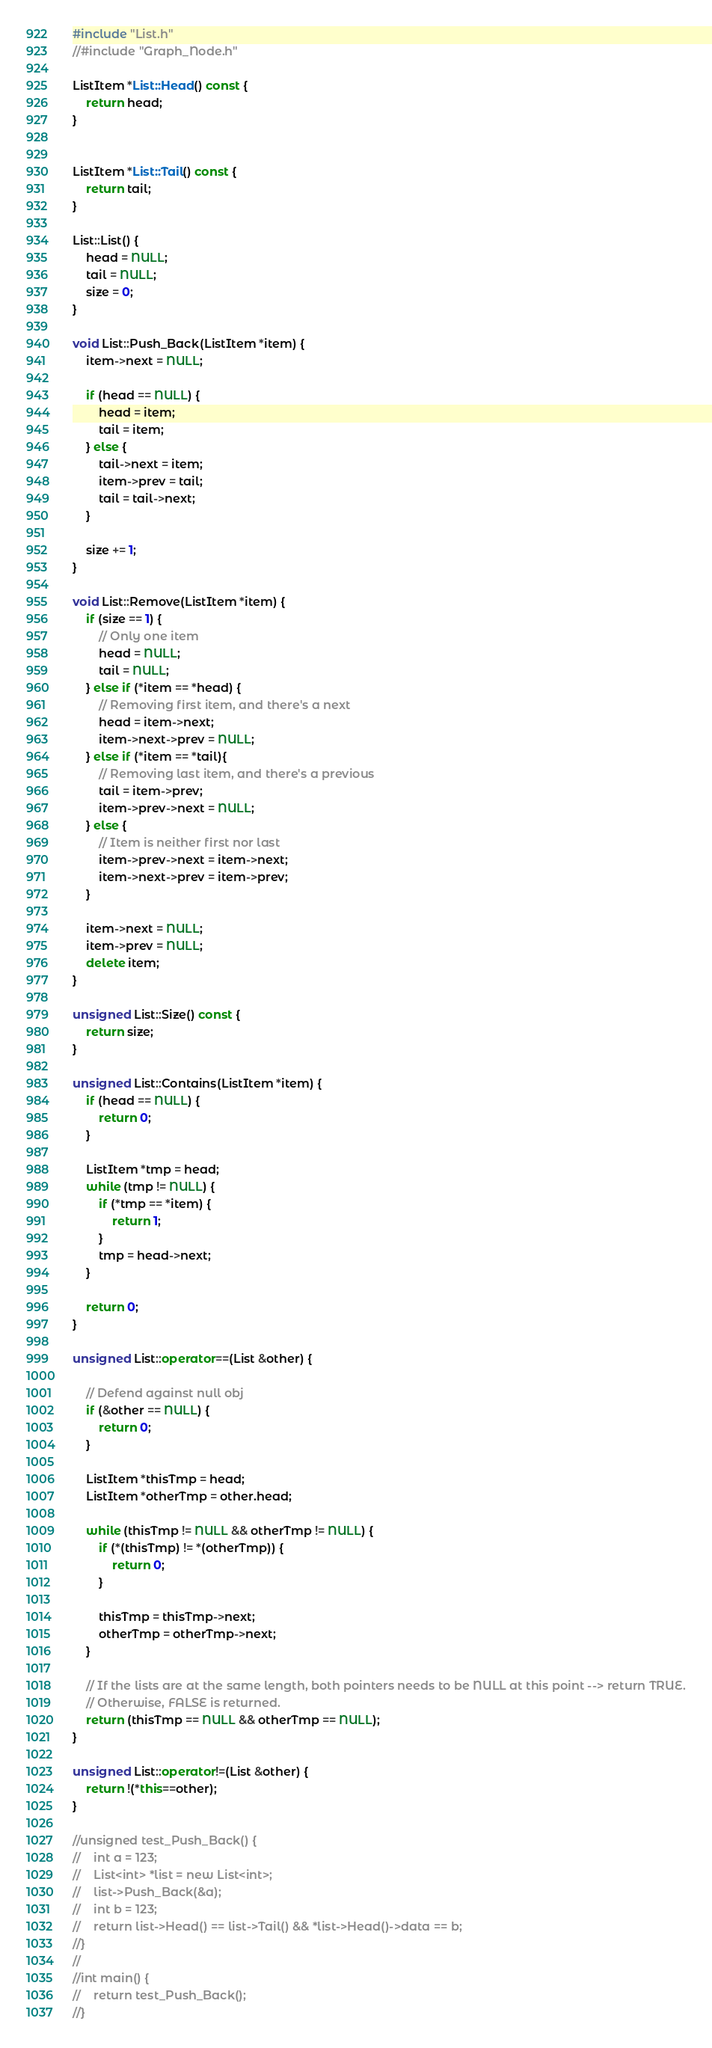<code> <loc_0><loc_0><loc_500><loc_500><_C++_>#include "List.h"
//#include "Graph_Node.h"

ListItem *List::Head() const {
    return head;
}


ListItem *List::Tail() const {
    return tail;
}

List::List() {
    head = NULL;
    tail = NULL;
    size = 0;
}

void List::Push_Back(ListItem *item) {
    item->next = NULL;

    if (head == NULL) {
        head = item;
        tail = item;
    } else {
        tail->next = item;
        item->prev = tail;
        tail = tail->next;
    }

    size += 1;
}

void List::Remove(ListItem *item) {
    if (size == 1) {
        // Only one item
        head = NULL;
        tail = NULL;
    } else if (*item == *head) {
        // Removing first item, and there's a next
        head = item->next;
        item->next->prev = NULL;
    } else if (*item == *tail){
        // Removing last item, and there's a previous
        tail = item->prev;
        item->prev->next = NULL;
    } else {
        // Item is neither first nor last
        item->prev->next = item->next;
        item->next->prev = item->prev;
    }

    item->next = NULL;
    item->prev = NULL;
    delete item;
}

unsigned List::Size() const {
    return size;
}

unsigned List::Contains(ListItem *item) {
    if (head == NULL) {
        return 0;
    }

    ListItem *tmp = head;
    while (tmp != NULL) {
        if (*tmp == *item) {
            return 1;
        }
        tmp = head->next;
    }

    return 0;
}

unsigned List::operator==(List &other) {

    // Defend against null obj
    if (&other == NULL) {
        return 0;
    }

    ListItem *thisTmp = head;
    ListItem *otherTmp = other.head;

    while (thisTmp != NULL && otherTmp != NULL) {
        if (*(thisTmp) != *(otherTmp)) {
            return 0;
        }

        thisTmp = thisTmp->next;
        otherTmp = otherTmp->next;
    }

    // If the lists are at the same length, both pointers needs to be NULL at this point --> return TRUE.
    // Otherwise, FALSE is returned.
    return (thisTmp == NULL && otherTmp == NULL);
}

unsigned List::operator!=(List &other) {
    return !(*this==other);
}

//unsigned test_Push_Back() {
//    int a = 123;
//    List<int> *list = new List<int>;
//    list->Push_Back(&a);
//    int b = 123;
//    return list->Head() == list->Tail() && *list->Head()->data == b;
//}
//
//int main() {
//    return test_Push_Back();
//}
</code> 